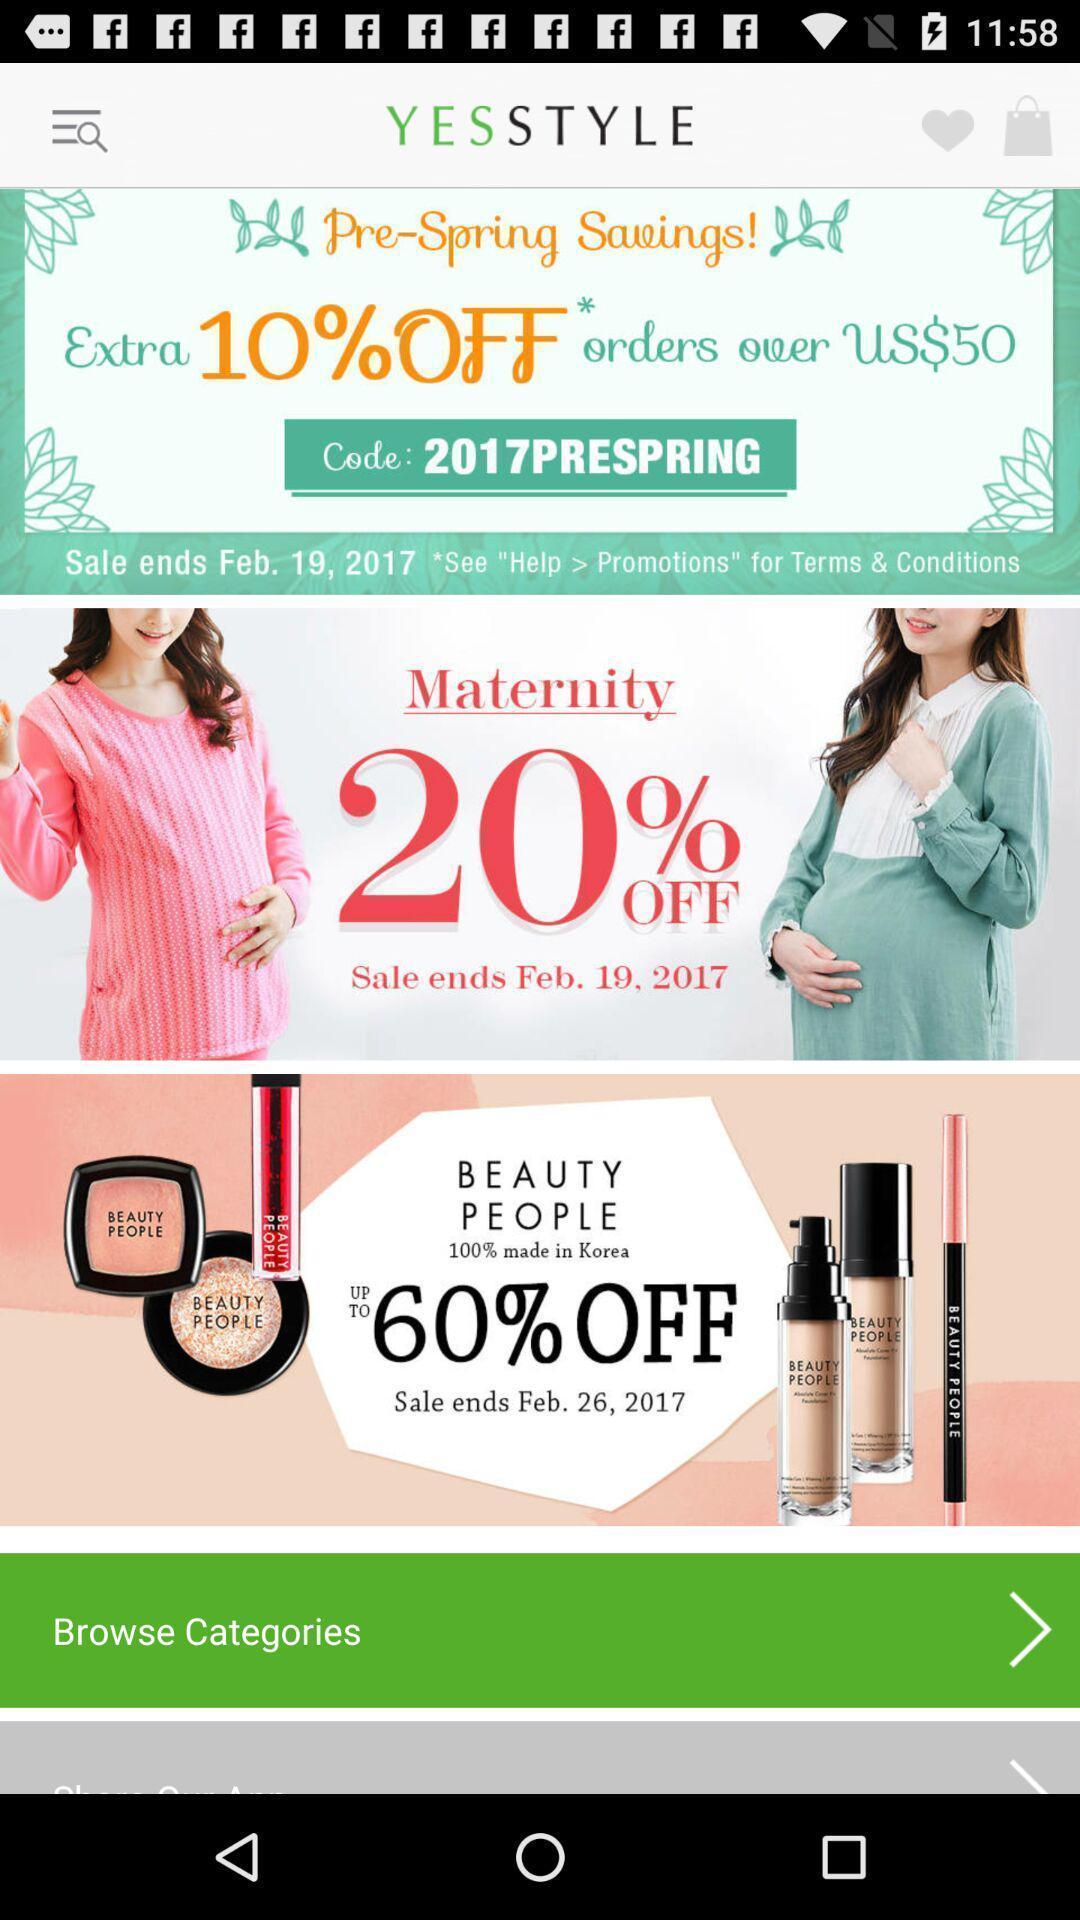Describe the key features of this screenshot. Page showing different products to buy. 